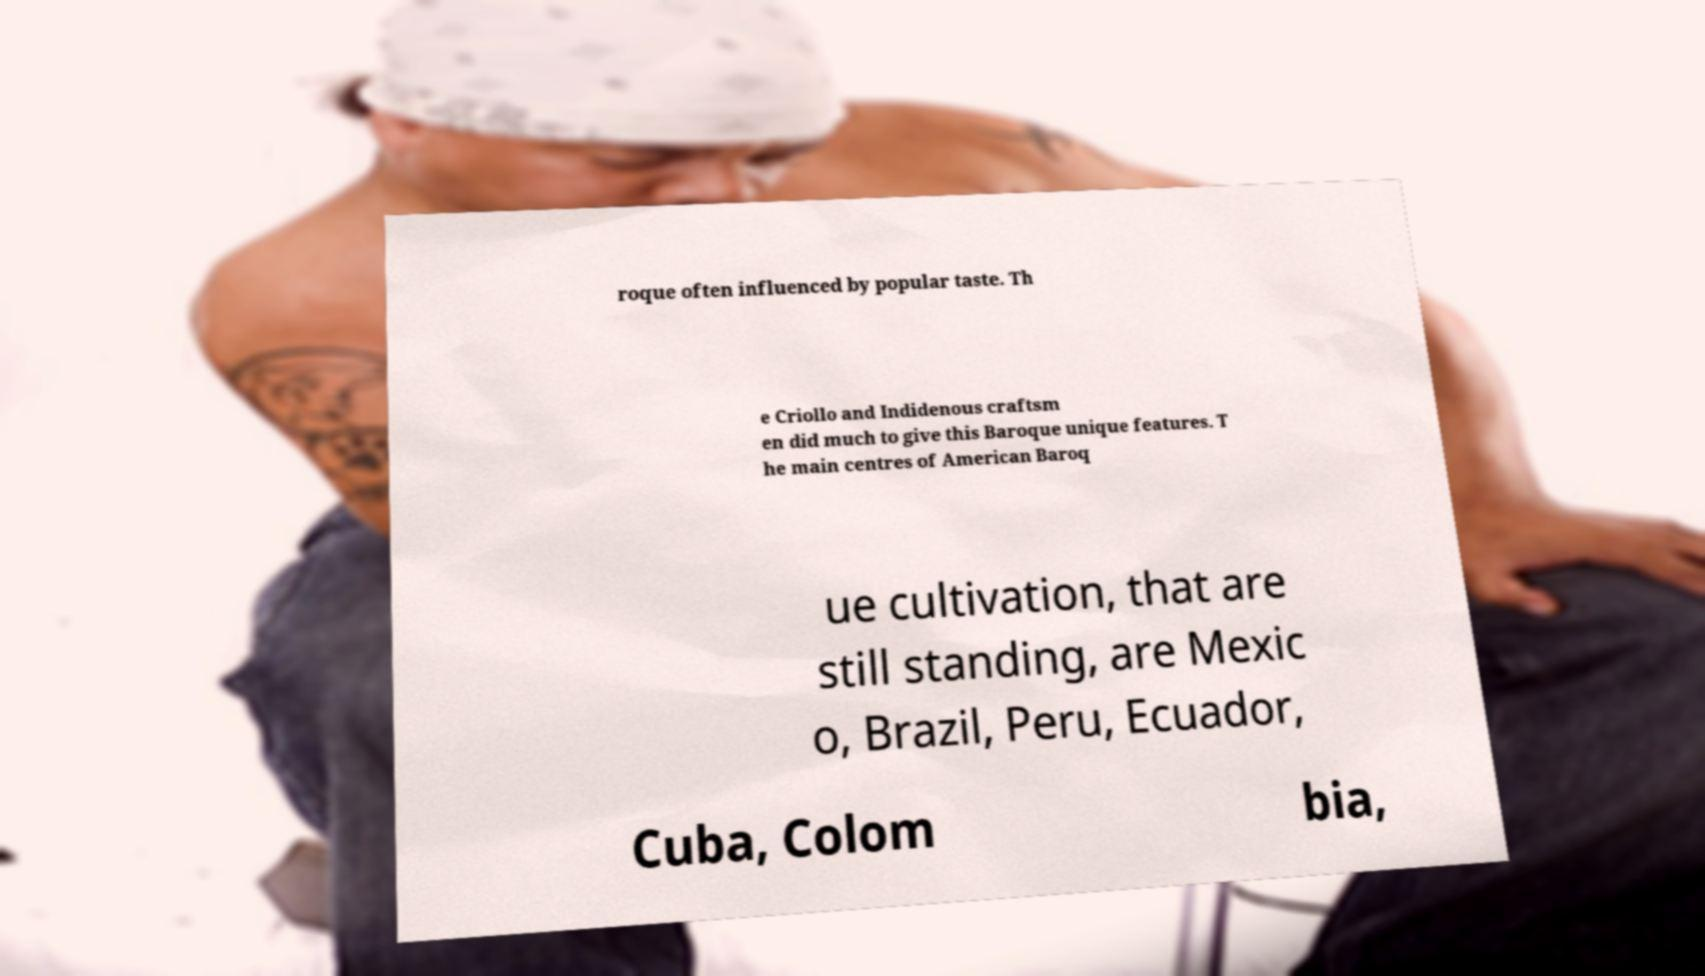Please identify and transcribe the text found in this image. roque often influenced by popular taste. Th e Criollo and Indidenous craftsm en did much to give this Baroque unique features. T he main centres of American Baroq ue cultivation, that are still standing, are Mexic o, Brazil, Peru, Ecuador, Cuba, Colom bia, 